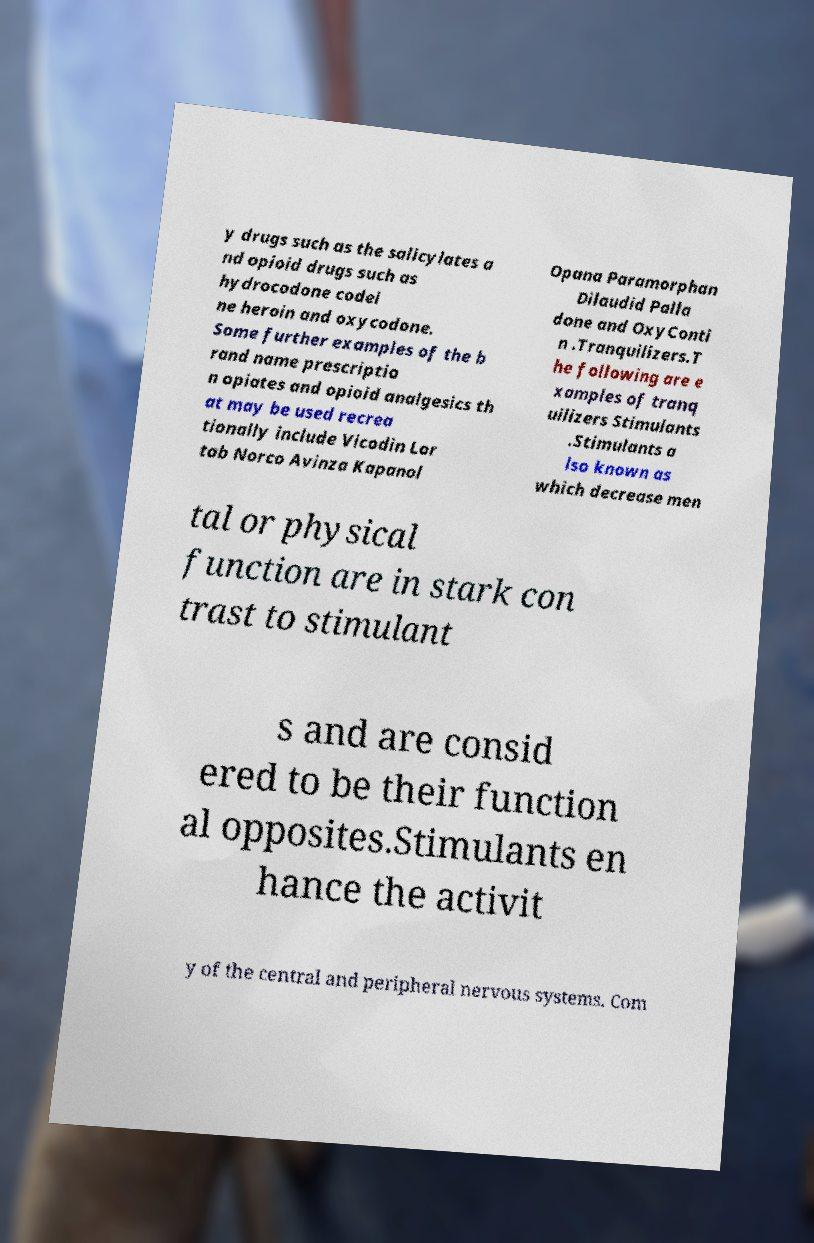Can you read and provide the text displayed in the image?This photo seems to have some interesting text. Can you extract and type it out for me? y drugs such as the salicylates a nd opioid drugs such as hydrocodone codei ne heroin and oxycodone. Some further examples of the b rand name prescriptio n opiates and opioid analgesics th at may be used recrea tionally include Vicodin Lor tab Norco Avinza Kapanol Opana Paramorphan Dilaudid Palla done and OxyConti n .Tranquilizers.T he following are e xamples of tranq uilizers Stimulants .Stimulants a lso known as which decrease men tal or physical function are in stark con trast to stimulant s and are consid ered to be their function al opposites.Stimulants en hance the activit y of the central and peripheral nervous systems. Com 